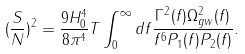Convert formula to latex. <formula><loc_0><loc_0><loc_500><loc_500>( \frac { S } { N } ) ^ { 2 } = \frac { 9 H _ { 0 } ^ { 4 } } { 8 \pi ^ { 4 } } T \int _ { 0 } ^ { \infty } d f \frac { \Gamma ^ { 2 } ( f ) \Omega _ { g w } ^ { 2 } ( f ) } { f ^ { 6 } P _ { 1 } ( f ) P _ { 2 } ( f ) } .</formula> 